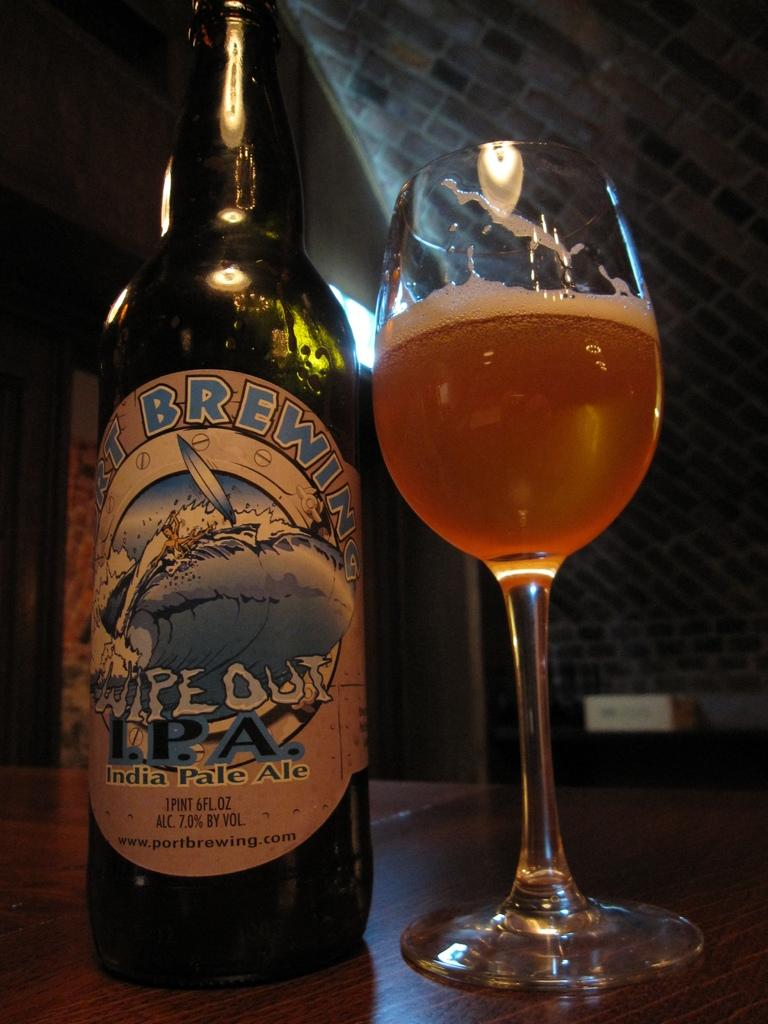<image>
Offer a succinct explanation of the picture presented. Wipe Out IPA beer has been poured into a wine glass 